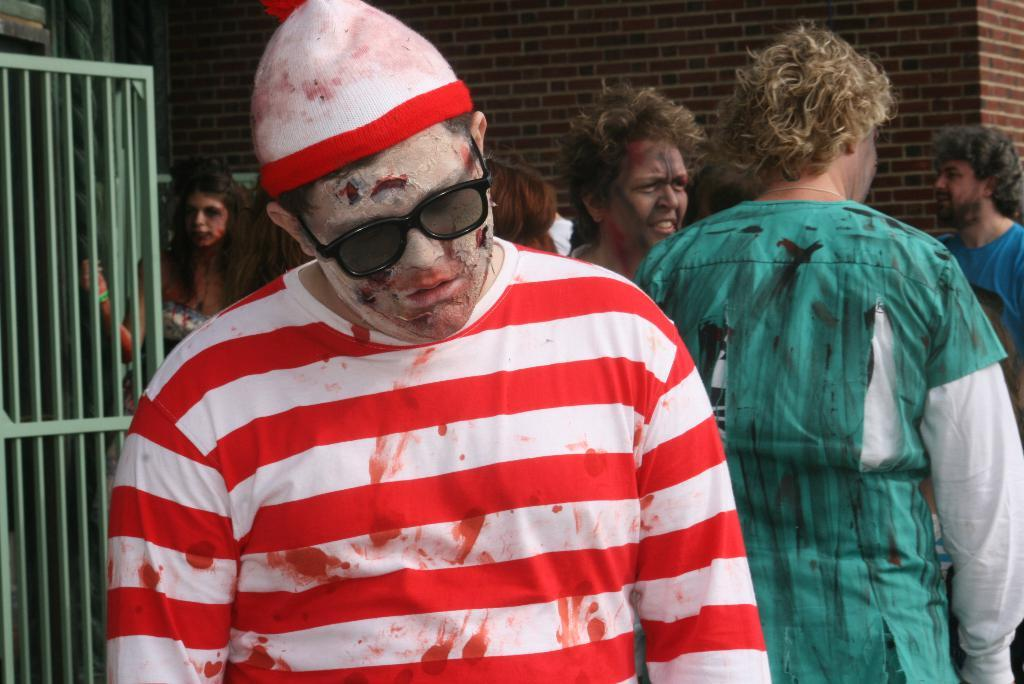Who or what can be seen in the image? There are people in the image. What object is present in the image that is typically used for cooking? There is a grill in the image. What type of structure can be seen in the background of the image? There is a brick wall in the background of the image. Can you describe the attire of one of the people in the image? A man in the image is wearing a cap and goggles. What type of milk is being poured into the grill in the image? There is no milk present in the image, and no one is pouring anything into the grill. What achievement is the man in the image celebrating? There is no indication of any achievement being celebrated in the image. 